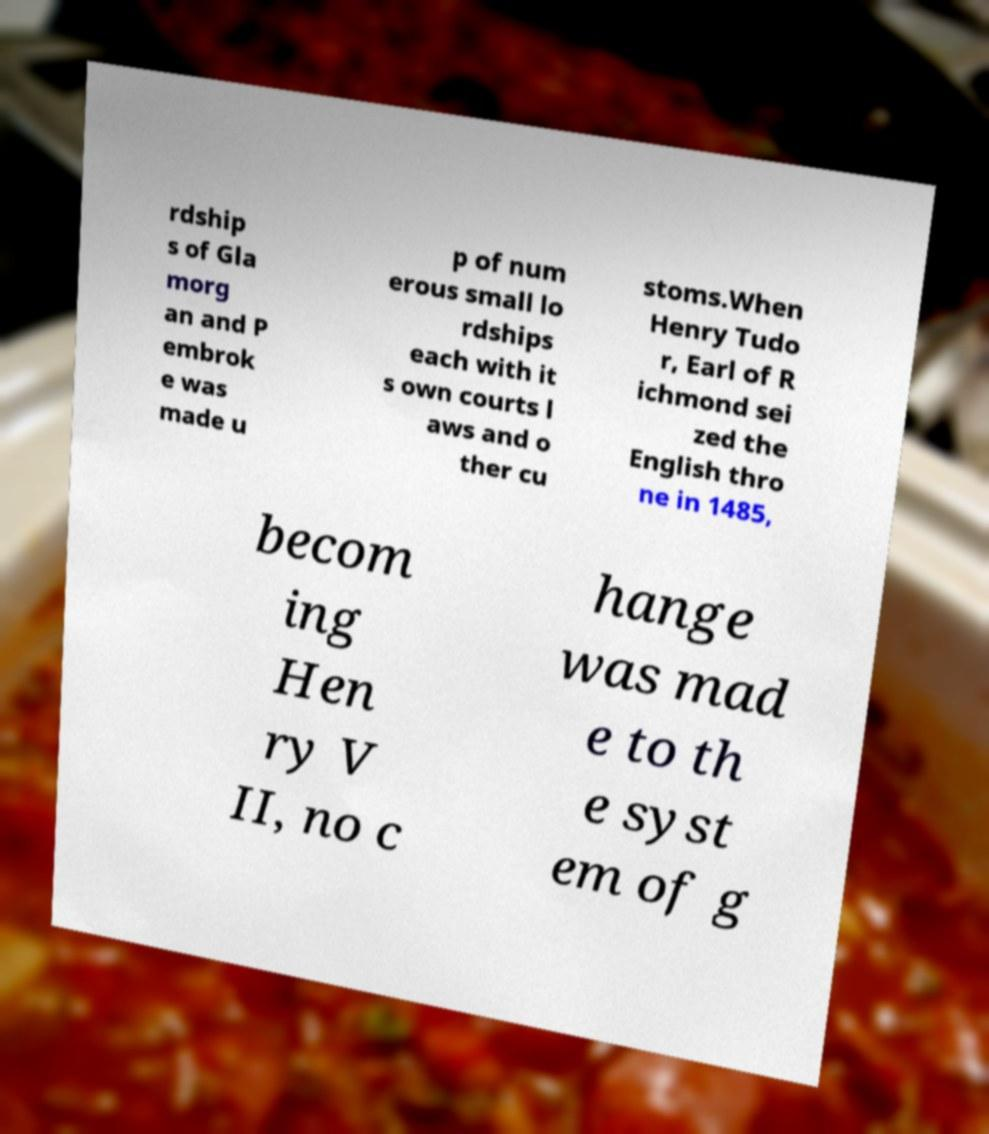Can you accurately transcribe the text from the provided image for me? rdship s of Gla morg an and P embrok e was made u p of num erous small lo rdships each with it s own courts l aws and o ther cu stoms.When Henry Tudo r, Earl of R ichmond sei zed the English thro ne in 1485, becom ing Hen ry V II, no c hange was mad e to th e syst em of g 